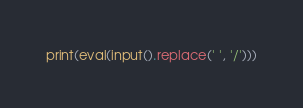<code> <loc_0><loc_0><loc_500><loc_500><_Python_>print(eval(input().replace(' ', '/')))</code> 